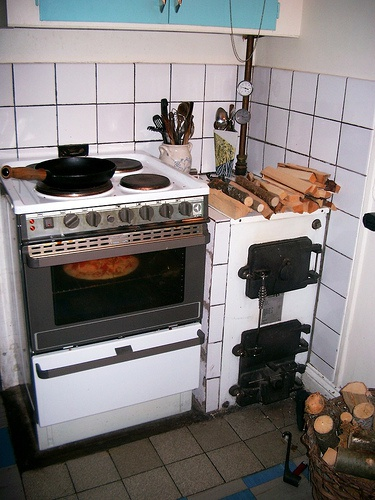Describe the objects in this image and their specific colors. I can see oven in black, lightgray, darkgray, and gray tones, pizza in black and maroon tones, spoon in black and gray tones, spoon in black, gray, and maroon tones, and spoon in black, gray, and darkgray tones in this image. 